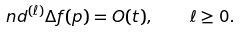<formula> <loc_0><loc_0><loc_500><loc_500>\ n d ^ { ( \ell ) } \Delta f ( p ) = O ( t ) , \quad \ell \geq 0 .</formula> 